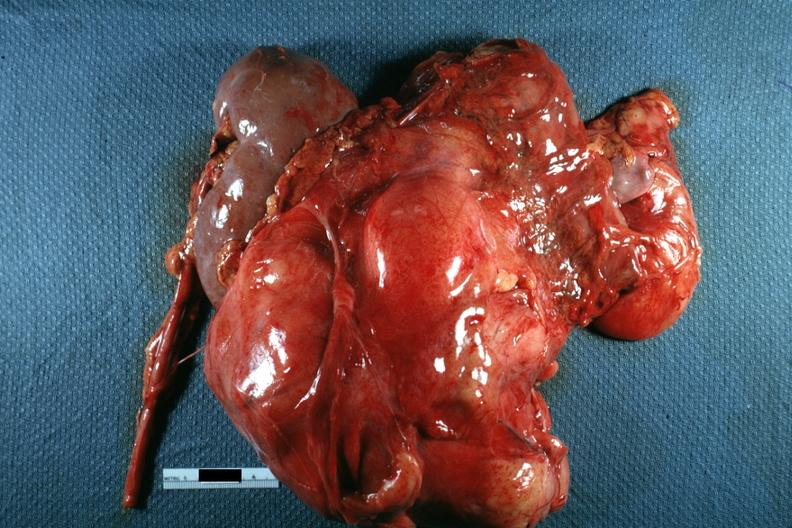what does this image show?
Answer the question using a single word or phrase. Nodular mass with kidney seen on one side photo of little use without showing cut surface 